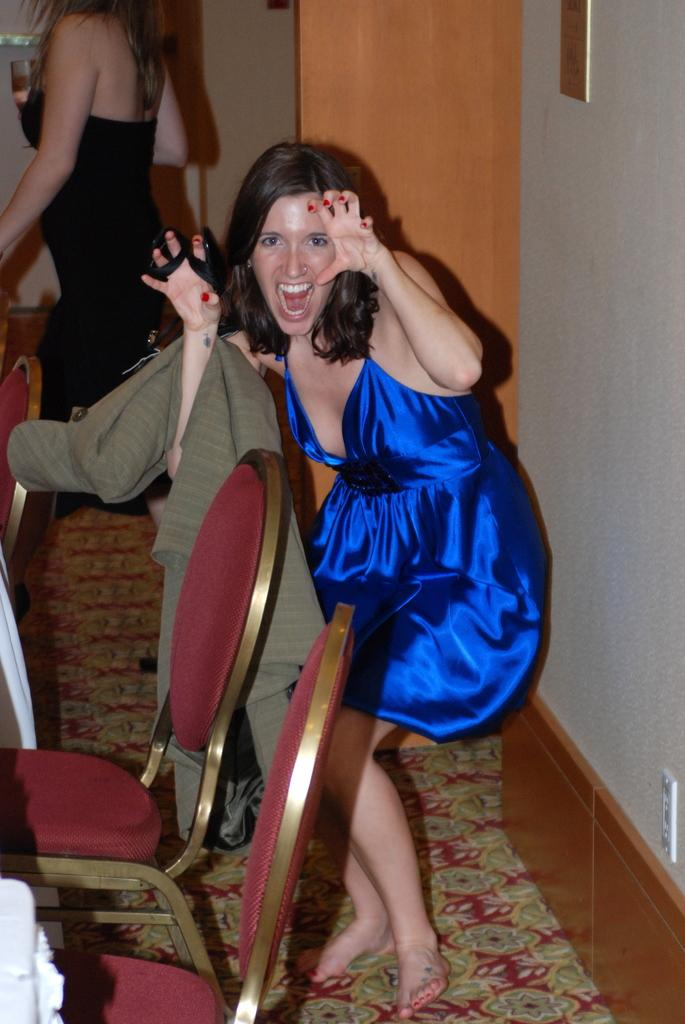What is the person in the foreground of the image wearing? The person is wearing a blue dress. Can you describe the person in the background of the image? The person in the background is holding a glass. What type of furniture is visible in the image? There are brown chairs visible in the image. How many people are present in the image? There are two people present in the image. How many chickens are present in the image? There are no chickens present in the image. What is the relationship between the two people in the image? The provided facts do not mention the relationship between the two people in the image. 